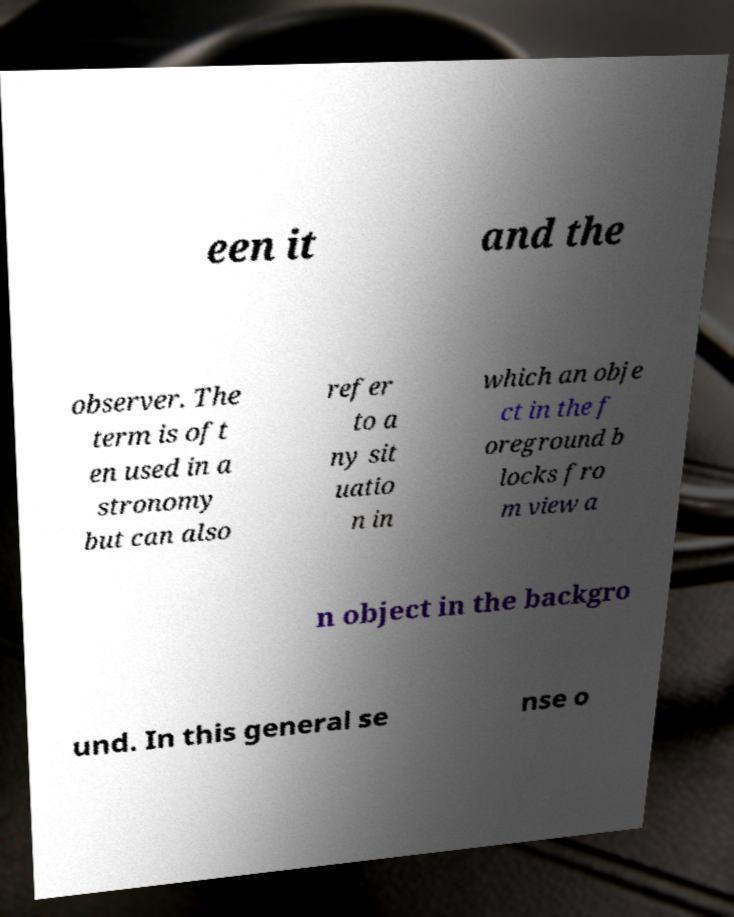I need the written content from this picture converted into text. Can you do that? een it and the observer. The term is oft en used in a stronomy but can also refer to a ny sit uatio n in which an obje ct in the f oreground b locks fro m view a n object in the backgro und. In this general se nse o 